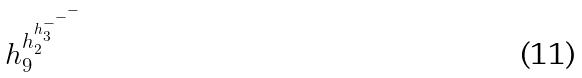<formula> <loc_0><loc_0><loc_500><loc_500>h _ { 9 } ^ { h _ { 2 } ^ { h _ { 3 } ^ { - ^ { - ^ { - } } } } }</formula> 